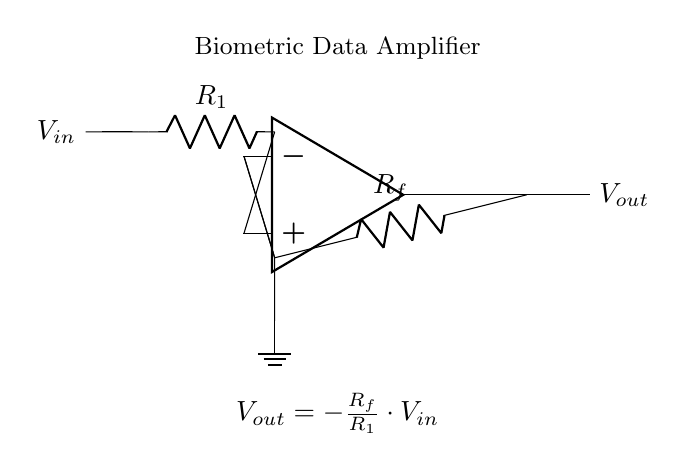What type of circuit is shown? The circuit is an operational amplifier circuit, which is specifically used for amplifying signals. It is characterized by the presence of an operational amplifier and feedback components.
Answer: Operational amplifier What does the variable Vin represent? Vin represents the input voltage to the operational amplifier, which is the voltage that will be amplified by the circuit. It is the voltage applied to the non-inverting input.
Answer: Input voltage What is the function of the resistor Rf? The resistor Rf is the feedback resistor that determines the gain of the operational amplifier. It forms a feedback loop to the inverting input and influences how much the amplifier amplifies the input signal.
Answer: Feedback resistor How is the gain of the amplifier calculated? The gain of the amplifier is calculated using the formula Vout = -Rf/R1 * Vin. This indicates that the output voltage is directly proportional to the input voltage and the ratio of Rf to R1.
Answer: Gain formula What happens to Vout if R1 is increased? If R1 is increased, the gain of the amplifier decreases. This is because a larger R1 in the gain formula reduces the overall fraction of Rf/R1, resulting in a smaller output voltage for the same input voltage.
Answer: Decreases What does the ground in the circuit signify? The ground in the circuit acts as a reference point for the voltages in the circuit. It is the common return path for electric current and serves as the zero voltage reference for all other voltages in the circuit.
Answer: Reference point Which component provides isolation for Vin from Vout? The operational amplifier itself provides isolation for Vin from Vout. This is due to its high input impedance and low output impedance, which prevents the load from affecting the input voltage.
Answer: Operational amplifier 